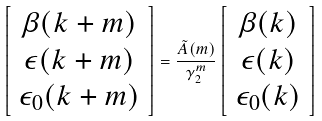Convert formula to latex. <formula><loc_0><loc_0><loc_500><loc_500>\left [ \begin{array} { c } \beta ( k + m ) \\ \epsilon ( k + m ) \\ \epsilon _ { 0 } ( k + m ) \end{array} \right ] = \frac { \tilde { A } ( m ) } { \gamma _ { 2 } ^ { m } } \left [ \begin{array} { c } \beta ( k ) \\ \epsilon ( k ) \\ \epsilon _ { 0 } ( k ) \end{array} \right ]</formula> 